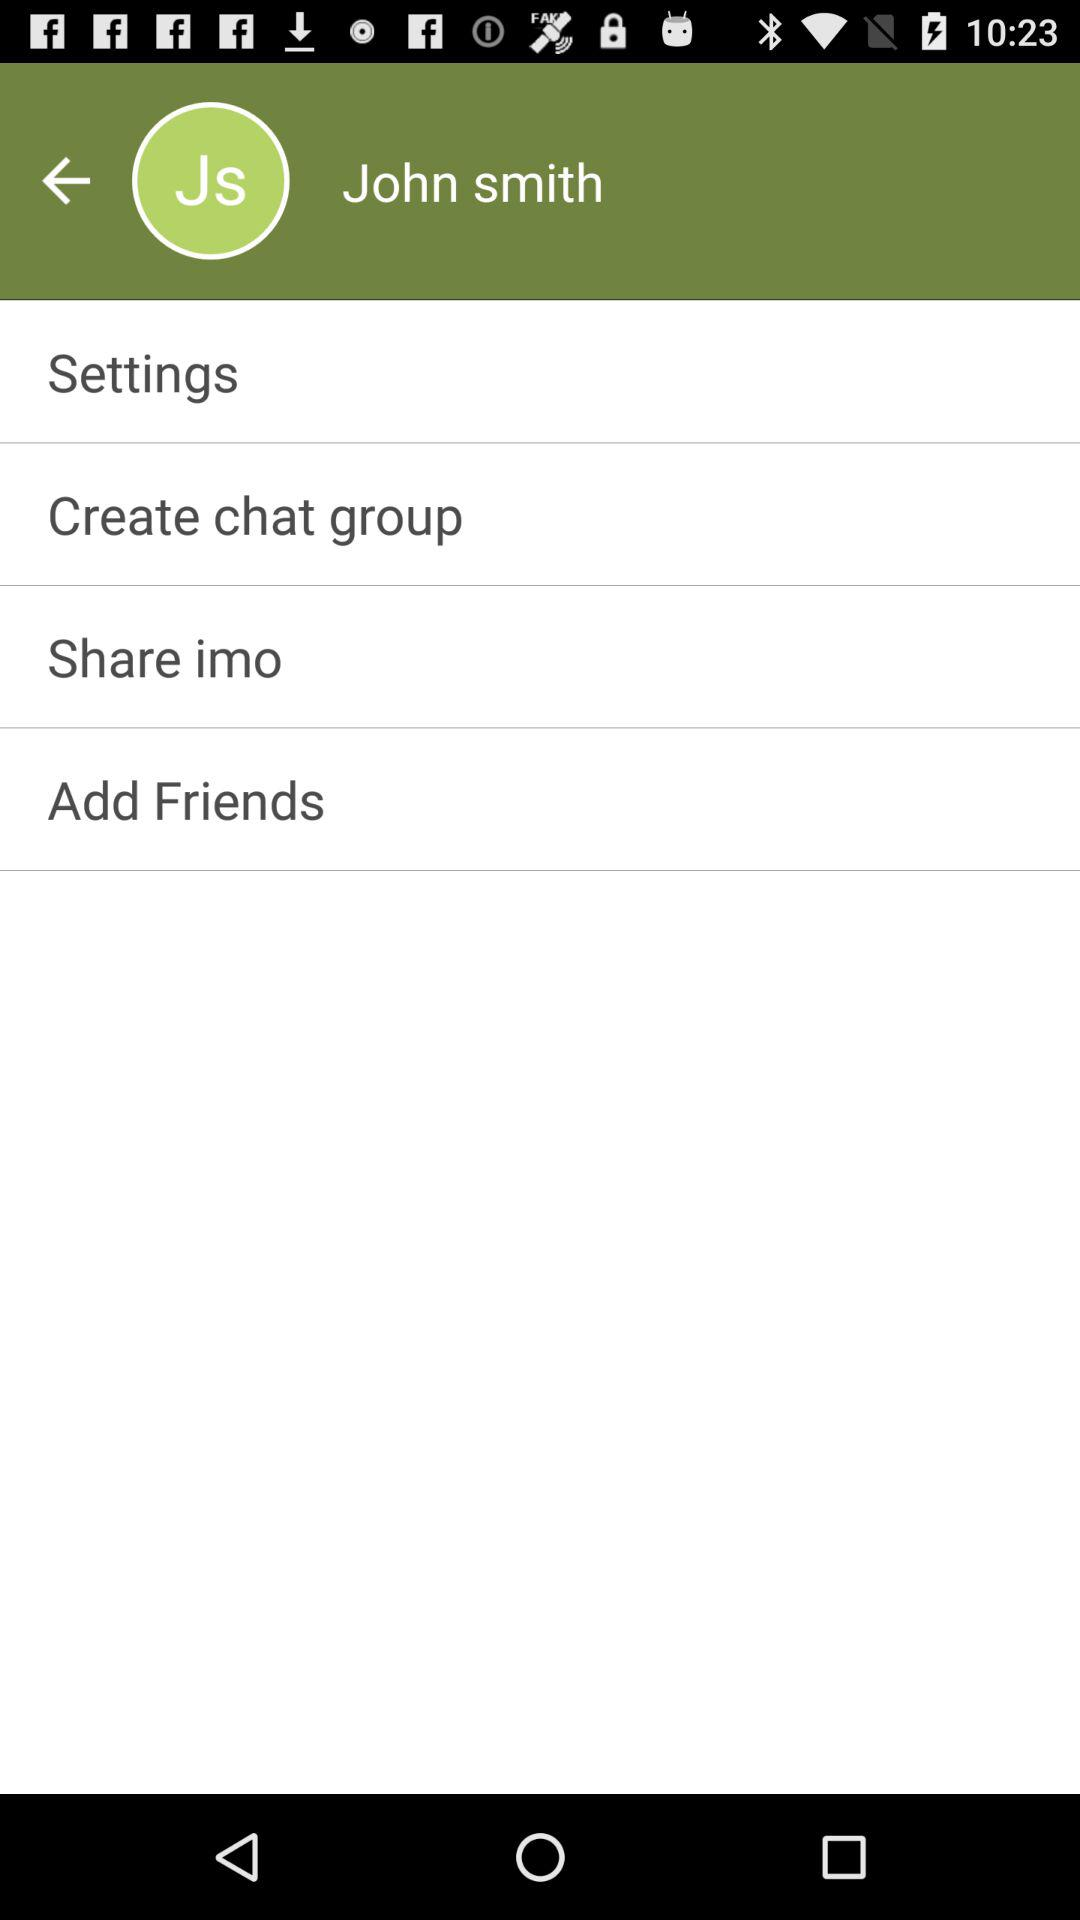How many friends have been added?
When the provided information is insufficient, respond with <no answer>. <no answer> 